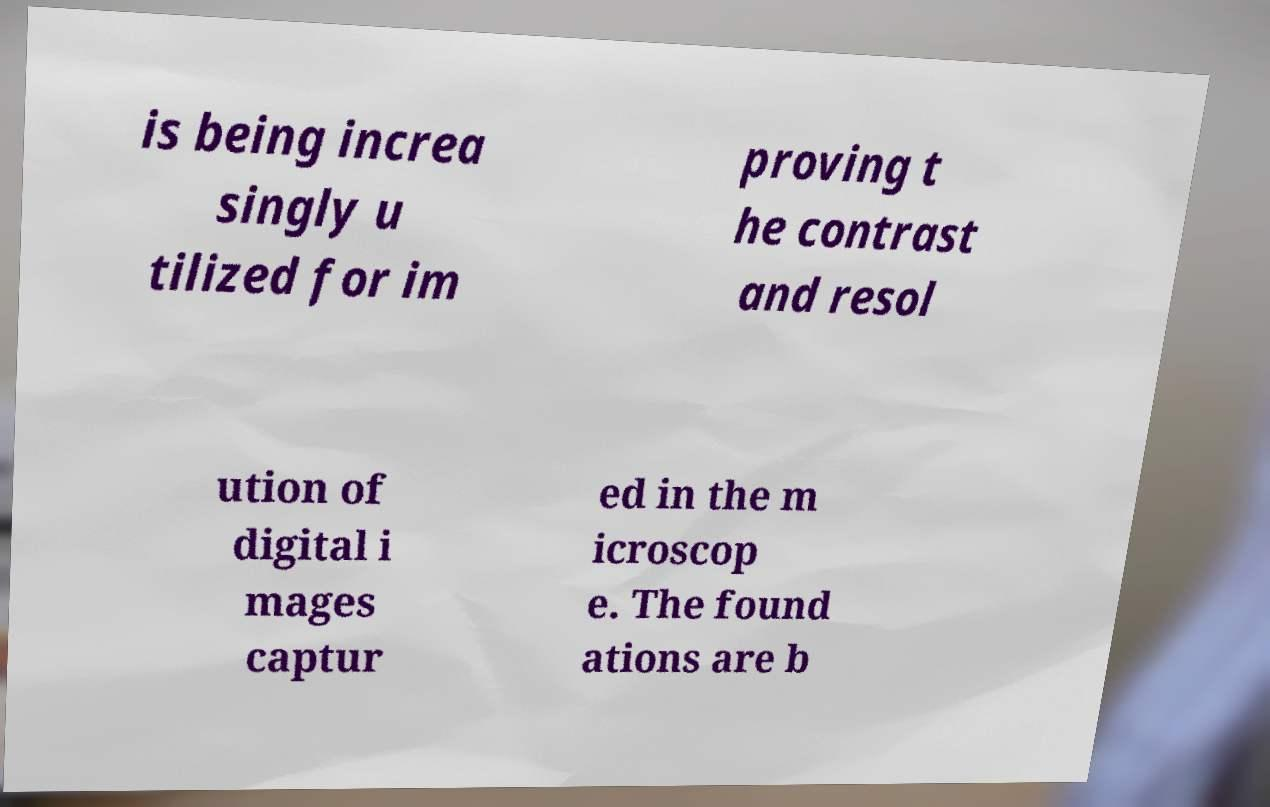Could you assist in decoding the text presented in this image and type it out clearly? is being increa singly u tilized for im proving t he contrast and resol ution of digital i mages captur ed in the m icroscop e. The found ations are b 